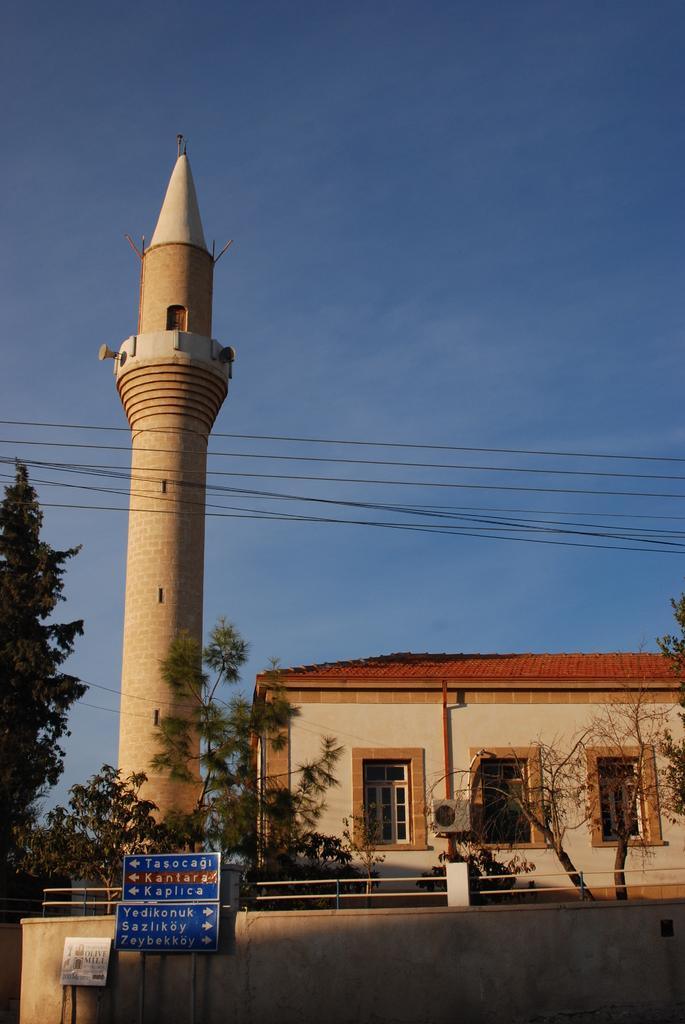What is the main structure in the image? There is a tower in the image. What other buildings or structures can be seen in the image? There is a building in the image. What type of vegetation is present in the image? There are trees in the image. What architectural feature can be seen in the image? There are windows and a wall in the image. What is present at the bottom of the image? There is a wall, boards, and rods at the bottom of the image. What can be seen in the background of the image? The sky is visible in the background of the image. What else is present in the image? There are wires in the image. Can you describe the journey of the shoes in the image? There are no shoes present in the image, so it is not possible to describe a journey for them. 